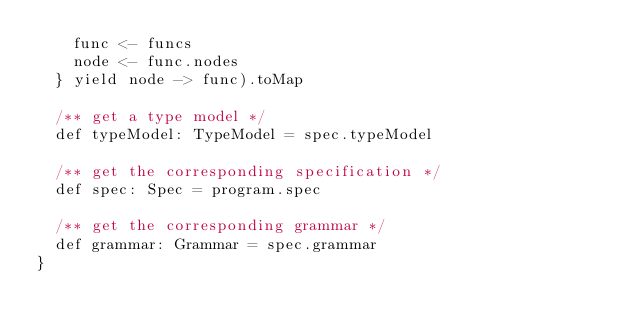Convert code to text. <code><loc_0><loc_0><loc_500><loc_500><_Scala_>    func <- funcs
    node <- func.nodes
  } yield node -> func).toMap

  /** get a type model */
  def typeModel: TypeModel = spec.typeModel

  /** get the corresponding specification */
  def spec: Spec = program.spec

  /** get the corresponding grammar */
  def grammar: Grammar = spec.grammar
}
</code> 